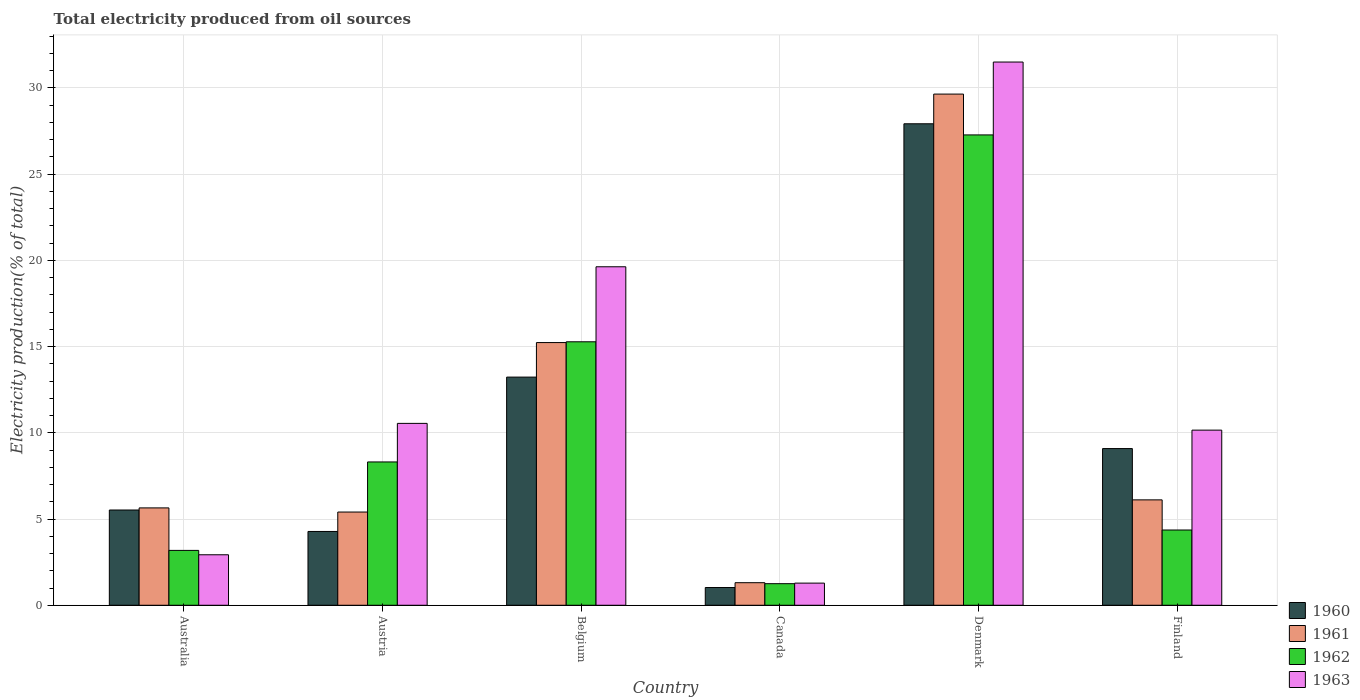How many different coloured bars are there?
Offer a very short reply. 4. How many groups of bars are there?
Provide a succinct answer. 6. Are the number of bars per tick equal to the number of legend labels?
Provide a short and direct response. Yes. How many bars are there on the 4th tick from the right?
Provide a short and direct response. 4. What is the label of the 4th group of bars from the left?
Your answer should be compact. Canada. In how many cases, is the number of bars for a given country not equal to the number of legend labels?
Offer a very short reply. 0. What is the total electricity produced in 1963 in Belgium?
Provide a succinct answer. 19.63. Across all countries, what is the maximum total electricity produced in 1960?
Give a very brief answer. 27.92. Across all countries, what is the minimum total electricity produced in 1961?
Make the answer very short. 1.31. In which country was the total electricity produced in 1962 minimum?
Provide a succinct answer. Canada. What is the total total electricity produced in 1962 in the graph?
Keep it short and to the point. 59.67. What is the difference between the total electricity produced in 1960 in Belgium and that in Canada?
Provide a short and direct response. 12.2. What is the difference between the total electricity produced in 1962 in Finland and the total electricity produced in 1960 in Austria?
Provide a succinct answer. 0.08. What is the average total electricity produced in 1961 per country?
Your response must be concise. 10.56. What is the difference between the total electricity produced of/in 1963 and total electricity produced of/in 1961 in Belgium?
Your answer should be compact. 4.4. What is the ratio of the total electricity produced in 1961 in Belgium to that in Denmark?
Make the answer very short. 0.51. What is the difference between the highest and the second highest total electricity produced in 1961?
Your response must be concise. 23.53. What is the difference between the highest and the lowest total electricity produced in 1963?
Provide a succinct answer. 30.22. In how many countries, is the total electricity produced in 1963 greater than the average total electricity produced in 1963 taken over all countries?
Provide a succinct answer. 2. What does the 1st bar from the right in Canada represents?
Your answer should be very brief. 1963. Is it the case that in every country, the sum of the total electricity produced in 1963 and total electricity produced in 1960 is greater than the total electricity produced in 1961?
Give a very brief answer. Yes. How many bars are there?
Offer a very short reply. 24. How many countries are there in the graph?
Your response must be concise. 6. Are the values on the major ticks of Y-axis written in scientific E-notation?
Your response must be concise. No. Does the graph contain any zero values?
Ensure brevity in your answer.  No. What is the title of the graph?
Keep it short and to the point. Total electricity produced from oil sources. Does "1991" appear as one of the legend labels in the graph?
Offer a terse response. No. What is the label or title of the X-axis?
Provide a succinct answer. Country. What is the Electricity production(% of total) of 1960 in Australia?
Offer a very short reply. 5.52. What is the Electricity production(% of total) of 1961 in Australia?
Provide a short and direct response. 5.65. What is the Electricity production(% of total) of 1962 in Australia?
Provide a short and direct response. 3.18. What is the Electricity production(% of total) of 1963 in Australia?
Your answer should be compact. 2.93. What is the Electricity production(% of total) in 1960 in Austria?
Provide a short and direct response. 4.28. What is the Electricity production(% of total) in 1961 in Austria?
Ensure brevity in your answer.  5.41. What is the Electricity production(% of total) in 1962 in Austria?
Make the answer very short. 8.31. What is the Electricity production(% of total) of 1963 in Austria?
Provide a succinct answer. 10.55. What is the Electricity production(% of total) in 1960 in Belgium?
Your answer should be compact. 13.23. What is the Electricity production(% of total) of 1961 in Belgium?
Your response must be concise. 15.23. What is the Electricity production(% of total) in 1962 in Belgium?
Provide a short and direct response. 15.28. What is the Electricity production(% of total) in 1963 in Belgium?
Ensure brevity in your answer.  19.63. What is the Electricity production(% of total) of 1960 in Canada?
Offer a very short reply. 1.03. What is the Electricity production(% of total) in 1961 in Canada?
Provide a short and direct response. 1.31. What is the Electricity production(% of total) of 1962 in Canada?
Keep it short and to the point. 1.25. What is the Electricity production(% of total) of 1963 in Canada?
Your answer should be very brief. 1.28. What is the Electricity production(% of total) in 1960 in Denmark?
Provide a short and direct response. 27.92. What is the Electricity production(% of total) in 1961 in Denmark?
Offer a terse response. 29.65. What is the Electricity production(% of total) in 1962 in Denmark?
Provide a succinct answer. 27.28. What is the Electricity production(% of total) of 1963 in Denmark?
Offer a very short reply. 31.51. What is the Electricity production(% of total) in 1960 in Finland?
Your answer should be very brief. 9.09. What is the Electricity production(% of total) in 1961 in Finland?
Offer a terse response. 6.11. What is the Electricity production(% of total) of 1962 in Finland?
Your answer should be very brief. 4.36. What is the Electricity production(% of total) in 1963 in Finland?
Your response must be concise. 10.16. Across all countries, what is the maximum Electricity production(% of total) in 1960?
Provide a short and direct response. 27.92. Across all countries, what is the maximum Electricity production(% of total) in 1961?
Provide a short and direct response. 29.65. Across all countries, what is the maximum Electricity production(% of total) in 1962?
Your response must be concise. 27.28. Across all countries, what is the maximum Electricity production(% of total) of 1963?
Ensure brevity in your answer.  31.51. Across all countries, what is the minimum Electricity production(% of total) in 1960?
Your answer should be very brief. 1.03. Across all countries, what is the minimum Electricity production(% of total) in 1961?
Make the answer very short. 1.31. Across all countries, what is the minimum Electricity production(% of total) of 1962?
Give a very brief answer. 1.25. Across all countries, what is the minimum Electricity production(% of total) of 1963?
Offer a very short reply. 1.28. What is the total Electricity production(% of total) of 1960 in the graph?
Keep it short and to the point. 61.08. What is the total Electricity production(% of total) in 1961 in the graph?
Your answer should be very brief. 63.36. What is the total Electricity production(% of total) of 1962 in the graph?
Offer a very short reply. 59.67. What is the total Electricity production(% of total) of 1963 in the graph?
Your answer should be very brief. 76.05. What is the difference between the Electricity production(% of total) in 1960 in Australia and that in Austria?
Your answer should be compact. 1.24. What is the difference between the Electricity production(% of total) of 1961 in Australia and that in Austria?
Your answer should be very brief. 0.24. What is the difference between the Electricity production(% of total) of 1962 in Australia and that in Austria?
Make the answer very short. -5.13. What is the difference between the Electricity production(% of total) of 1963 in Australia and that in Austria?
Offer a very short reply. -7.62. What is the difference between the Electricity production(% of total) of 1960 in Australia and that in Belgium?
Offer a terse response. -7.71. What is the difference between the Electricity production(% of total) of 1961 in Australia and that in Belgium?
Make the answer very short. -9.59. What is the difference between the Electricity production(% of total) in 1962 in Australia and that in Belgium?
Ensure brevity in your answer.  -12.1. What is the difference between the Electricity production(% of total) of 1963 in Australia and that in Belgium?
Offer a terse response. -16.7. What is the difference between the Electricity production(% of total) of 1960 in Australia and that in Canada?
Offer a terse response. 4.5. What is the difference between the Electricity production(% of total) in 1961 in Australia and that in Canada?
Your answer should be compact. 4.34. What is the difference between the Electricity production(% of total) of 1962 in Australia and that in Canada?
Your response must be concise. 1.93. What is the difference between the Electricity production(% of total) in 1963 in Australia and that in Canada?
Ensure brevity in your answer.  1.64. What is the difference between the Electricity production(% of total) of 1960 in Australia and that in Denmark?
Provide a succinct answer. -22.4. What is the difference between the Electricity production(% of total) of 1961 in Australia and that in Denmark?
Offer a very short reply. -24. What is the difference between the Electricity production(% of total) of 1962 in Australia and that in Denmark?
Keep it short and to the point. -24.1. What is the difference between the Electricity production(% of total) in 1963 in Australia and that in Denmark?
Ensure brevity in your answer.  -28.58. What is the difference between the Electricity production(% of total) of 1960 in Australia and that in Finland?
Offer a very short reply. -3.56. What is the difference between the Electricity production(% of total) in 1961 in Australia and that in Finland?
Provide a succinct answer. -0.47. What is the difference between the Electricity production(% of total) in 1962 in Australia and that in Finland?
Your response must be concise. -1.18. What is the difference between the Electricity production(% of total) of 1963 in Australia and that in Finland?
Ensure brevity in your answer.  -7.23. What is the difference between the Electricity production(% of total) of 1960 in Austria and that in Belgium?
Keep it short and to the point. -8.95. What is the difference between the Electricity production(% of total) in 1961 in Austria and that in Belgium?
Keep it short and to the point. -9.83. What is the difference between the Electricity production(% of total) in 1962 in Austria and that in Belgium?
Your answer should be compact. -6.97. What is the difference between the Electricity production(% of total) in 1963 in Austria and that in Belgium?
Make the answer very short. -9.08. What is the difference between the Electricity production(% of total) in 1960 in Austria and that in Canada?
Ensure brevity in your answer.  3.25. What is the difference between the Electricity production(% of total) of 1961 in Austria and that in Canada?
Your response must be concise. 4.1. What is the difference between the Electricity production(% of total) in 1962 in Austria and that in Canada?
Make the answer very short. 7.06. What is the difference between the Electricity production(% of total) in 1963 in Austria and that in Canada?
Your response must be concise. 9.26. What is the difference between the Electricity production(% of total) of 1960 in Austria and that in Denmark?
Give a very brief answer. -23.64. What is the difference between the Electricity production(% of total) of 1961 in Austria and that in Denmark?
Your response must be concise. -24.24. What is the difference between the Electricity production(% of total) of 1962 in Austria and that in Denmark?
Ensure brevity in your answer.  -18.97. What is the difference between the Electricity production(% of total) of 1963 in Austria and that in Denmark?
Your response must be concise. -20.96. What is the difference between the Electricity production(% of total) of 1960 in Austria and that in Finland?
Offer a terse response. -4.81. What is the difference between the Electricity production(% of total) in 1961 in Austria and that in Finland?
Keep it short and to the point. -0.71. What is the difference between the Electricity production(% of total) of 1962 in Austria and that in Finland?
Give a very brief answer. 3.95. What is the difference between the Electricity production(% of total) of 1963 in Austria and that in Finland?
Ensure brevity in your answer.  0.39. What is the difference between the Electricity production(% of total) of 1960 in Belgium and that in Canada?
Your answer should be compact. 12.2. What is the difference between the Electricity production(% of total) of 1961 in Belgium and that in Canada?
Your response must be concise. 13.93. What is the difference between the Electricity production(% of total) of 1962 in Belgium and that in Canada?
Your response must be concise. 14.03. What is the difference between the Electricity production(% of total) in 1963 in Belgium and that in Canada?
Give a very brief answer. 18.35. What is the difference between the Electricity production(% of total) in 1960 in Belgium and that in Denmark?
Your answer should be very brief. -14.69. What is the difference between the Electricity production(% of total) in 1961 in Belgium and that in Denmark?
Keep it short and to the point. -14.41. What is the difference between the Electricity production(% of total) of 1962 in Belgium and that in Denmark?
Your answer should be compact. -12. What is the difference between the Electricity production(% of total) in 1963 in Belgium and that in Denmark?
Give a very brief answer. -11.87. What is the difference between the Electricity production(% of total) of 1960 in Belgium and that in Finland?
Provide a succinct answer. 4.14. What is the difference between the Electricity production(% of total) in 1961 in Belgium and that in Finland?
Your answer should be very brief. 9.12. What is the difference between the Electricity production(% of total) in 1962 in Belgium and that in Finland?
Offer a terse response. 10.92. What is the difference between the Electricity production(% of total) of 1963 in Belgium and that in Finland?
Offer a very short reply. 9.47. What is the difference between the Electricity production(% of total) in 1960 in Canada and that in Denmark?
Keep it short and to the point. -26.9. What is the difference between the Electricity production(% of total) of 1961 in Canada and that in Denmark?
Give a very brief answer. -28.34. What is the difference between the Electricity production(% of total) in 1962 in Canada and that in Denmark?
Your answer should be compact. -26.03. What is the difference between the Electricity production(% of total) of 1963 in Canada and that in Denmark?
Give a very brief answer. -30.22. What is the difference between the Electricity production(% of total) of 1960 in Canada and that in Finland?
Your response must be concise. -8.06. What is the difference between the Electricity production(% of total) in 1961 in Canada and that in Finland?
Give a very brief answer. -4.8. What is the difference between the Electricity production(% of total) in 1962 in Canada and that in Finland?
Ensure brevity in your answer.  -3.11. What is the difference between the Electricity production(% of total) in 1963 in Canada and that in Finland?
Your response must be concise. -8.87. What is the difference between the Electricity production(% of total) in 1960 in Denmark and that in Finland?
Your answer should be very brief. 18.84. What is the difference between the Electricity production(% of total) of 1961 in Denmark and that in Finland?
Make the answer very short. 23.53. What is the difference between the Electricity production(% of total) of 1962 in Denmark and that in Finland?
Keep it short and to the point. 22.91. What is the difference between the Electricity production(% of total) in 1963 in Denmark and that in Finland?
Offer a very short reply. 21.35. What is the difference between the Electricity production(% of total) of 1960 in Australia and the Electricity production(% of total) of 1961 in Austria?
Your response must be concise. 0.12. What is the difference between the Electricity production(% of total) in 1960 in Australia and the Electricity production(% of total) in 1962 in Austria?
Ensure brevity in your answer.  -2.79. What is the difference between the Electricity production(% of total) in 1960 in Australia and the Electricity production(% of total) in 1963 in Austria?
Your answer should be very brief. -5.02. What is the difference between the Electricity production(% of total) of 1961 in Australia and the Electricity production(% of total) of 1962 in Austria?
Make the answer very short. -2.67. What is the difference between the Electricity production(% of total) in 1961 in Australia and the Electricity production(% of total) in 1963 in Austria?
Make the answer very short. -4.9. What is the difference between the Electricity production(% of total) of 1962 in Australia and the Electricity production(% of total) of 1963 in Austria?
Your answer should be very brief. -7.37. What is the difference between the Electricity production(% of total) in 1960 in Australia and the Electricity production(% of total) in 1961 in Belgium?
Your answer should be very brief. -9.71. What is the difference between the Electricity production(% of total) in 1960 in Australia and the Electricity production(% of total) in 1962 in Belgium?
Keep it short and to the point. -9.76. What is the difference between the Electricity production(% of total) of 1960 in Australia and the Electricity production(% of total) of 1963 in Belgium?
Your answer should be very brief. -14.11. What is the difference between the Electricity production(% of total) of 1961 in Australia and the Electricity production(% of total) of 1962 in Belgium?
Provide a short and direct response. -9.63. What is the difference between the Electricity production(% of total) of 1961 in Australia and the Electricity production(% of total) of 1963 in Belgium?
Give a very brief answer. -13.98. What is the difference between the Electricity production(% of total) of 1962 in Australia and the Electricity production(% of total) of 1963 in Belgium?
Make the answer very short. -16.45. What is the difference between the Electricity production(% of total) in 1960 in Australia and the Electricity production(% of total) in 1961 in Canada?
Ensure brevity in your answer.  4.22. What is the difference between the Electricity production(% of total) in 1960 in Australia and the Electricity production(% of total) in 1962 in Canada?
Provide a short and direct response. 4.27. What is the difference between the Electricity production(% of total) in 1960 in Australia and the Electricity production(% of total) in 1963 in Canada?
Offer a very short reply. 4.24. What is the difference between the Electricity production(% of total) of 1961 in Australia and the Electricity production(% of total) of 1962 in Canada?
Offer a very short reply. 4.4. What is the difference between the Electricity production(% of total) in 1961 in Australia and the Electricity production(% of total) in 1963 in Canada?
Make the answer very short. 4.36. What is the difference between the Electricity production(% of total) of 1962 in Australia and the Electricity production(% of total) of 1963 in Canada?
Your answer should be compact. 1.9. What is the difference between the Electricity production(% of total) of 1960 in Australia and the Electricity production(% of total) of 1961 in Denmark?
Make the answer very short. -24.12. What is the difference between the Electricity production(% of total) in 1960 in Australia and the Electricity production(% of total) in 1962 in Denmark?
Ensure brevity in your answer.  -21.75. What is the difference between the Electricity production(% of total) in 1960 in Australia and the Electricity production(% of total) in 1963 in Denmark?
Provide a succinct answer. -25.98. What is the difference between the Electricity production(% of total) of 1961 in Australia and the Electricity production(% of total) of 1962 in Denmark?
Your response must be concise. -21.63. What is the difference between the Electricity production(% of total) of 1961 in Australia and the Electricity production(% of total) of 1963 in Denmark?
Make the answer very short. -25.86. What is the difference between the Electricity production(% of total) of 1962 in Australia and the Electricity production(% of total) of 1963 in Denmark?
Your answer should be very brief. -28.32. What is the difference between the Electricity production(% of total) in 1960 in Australia and the Electricity production(% of total) in 1961 in Finland?
Provide a succinct answer. -0.59. What is the difference between the Electricity production(% of total) of 1960 in Australia and the Electricity production(% of total) of 1962 in Finland?
Keep it short and to the point. 1.16. What is the difference between the Electricity production(% of total) in 1960 in Australia and the Electricity production(% of total) in 1963 in Finland?
Ensure brevity in your answer.  -4.63. What is the difference between the Electricity production(% of total) of 1961 in Australia and the Electricity production(% of total) of 1962 in Finland?
Keep it short and to the point. 1.28. What is the difference between the Electricity production(% of total) in 1961 in Australia and the Electricity production(% of total) in 1963 in Finland?
Provide a short and direct response. -4.51. What is the difference between the Electricity production(% of total) in 1962 in Australia and the Electricity production(% of total) in 1963 in Finland?
Provide a succinct answer. -6.98. What is the difference between the Electricity production(% of total) in 1960 in Austria and the Electricity production(% of total) in 1961 in Belgium?
Provide a succinct answer. -10.95. What is the difference between the Electricity production(% of total) in 1960 in Austria and the Electricity production(% of total) in 1962 in Belgium?
Offer a very short reply. -11. What is the difference between the Electricity production(% of total) of 1960 in Austria and the Electricity production(% of total) of 1963 in Belgium?
Provide a short and direct response. -15.35. What is the difference between the Electricity production(% of total) of 1961 in Austria and the Electricity production(% of total) of 1962 in Belgium?
Keep it short and to the point. -9.87. What is the difference between the Electricity production(% of total) in 1961 in Austria and the Electricity production(% of total) in 1963 in Belgium?
Your answer should be compact. -14.22. What is the difference between the Electricity production(% of total) of 1962 in Austria and the Electricity production(% of total) of 1963 in Belgium?
Ensure brevity in your answer.  -11.32. What is the difference between the Electricity production(% of total) of 1960 in Austria and the Electricity production(% of total) of 1961 in Canada?
Make the answer very short. 2.97. What is the difference between the Electricity production(% of total) in 1960 in Austria and the Electricity production(% of total) in 1962 in Canada?
Give a very brief answer. 3.03. What is the difference between the Electricity production(% of total) in 1960 in Austria and the Electricity production(% of total) in 1963 in Canada?
Give a very brief answer. 3. What is the difference between the Electricity production(% of total) in 1961 in Austria and the Electricity production(% of total) in 1962 in Canada?
Your answer should be very brief. 4.16. What is the difference between the Electricity production(% of total) in 1961 in Austria and the Electricity production(% of total) in 1963 in Canada?
Your response must be concise. 4.12. What is the difference between the Electricity production(% of total) in 1962 in Austria and the Electricity production(% of total) in 1963 in Canada?
Your answer should be very brief. 7.03. What is the difference between the Electricity production(% of total) of 1960 in Austria and the Electricity production(% of total) of 1961 in Denmark?
Offer a terse response. -25.37. What is the difference between the Electricity production(% of total) of 1960 in Austria and the Electricity production(% of total) of 1962 in Denmark?
Give a very brief answer. -23. What is the difference between the Electricity production(% of total) in 1960 in Austria and the Electricity production(% of total) in 1963 in Denmark?
Keep it short and to the point. -27.22. What is the difference between the Electricity production(% of total) in 1961 in Austria and the Electricity production(% of total) in 1962 in Denmark?
Offer a very short reply. -21.87. What is the difference between the Electricity production(% of total) in 1961 in Austria and the Electricity production(% of total) in 1963 in Denmark?
Make the answer very short. -26.1. What is the difference between the Electricity production(% of total) in 1962 in Austria and the Electricity production(% of total) in 1963 in Denmark?
Your answer should be very brief. -23.19. What is the difference between the Electricity production(% of total) of 1960 in Austria and the Electricity production(% of total) of 1961 in Finland?
Your answer should be very brief. -1.83. What is the difference between the Electricity production(% of total) in 1960 in Austria and the Electricity production(% of total) in 1962 in Finland?
Your answer should be compact. -0.08. What is the difference between the Electricity production(% of total) of 1960 in Austria and the Electricity production(% of total) of 1963 in Finland?
Make the answer very short. -5.88. What is the difference between the Electricity production(% of total) in 1961 in Austria and the Electricity production(% of total) in 1962 in Finland?
Your response must be concise. 1.04. What is the difference between the Electricity production(% of total) in 1961 in Austria and the Electricity production(% of total) in 1963 in Finland?
Ensure brevity in your answer.  -4.75. What is the difference between the Electricity production(% of total) of 1962 in Austria and the Electricity production(% of total) of 1963 in Finland?
Your answer should be compact. -1.84. What is the difference between the Electricity production(% of total) of 1960 in Belgium and the Electricity production(% of total) of 1961 in Canada?
Give a very brief answer. 11.92. What is the difference between the Electricity production(% of total) of 1960 in Belgium and the Electricity production(% of total) of 1962 in Canada?
Your answer should be very brief. 11.98. What is the difference between the Electricity production(% of total) in 1960 in Belgium and the Electricity production(% of total) in 1963 in Canada?
Provide a succinct answer. 11.95. What is the difference between the Electricity production(% of total) of 1961 in Belgium and the Electricity production(% of total) of 1962 in Canada?
Ensure brevity in your answer.  13.98. What is the difference between the Electricity production(% of total) of 1961 in Belgium and the Electricity production(% of total) of 1963 in Canada?
Your response must be concise. 13.95. What is the difference between the Electricity production(% of total) of 1962 in Belgium and the Electricity production(% of total) of 1963 in Canada?
Your answer should be very brief. 14. What is the difference between the Electricity production(% of total) of 1960 in Belgium and the Electricity production(% of total) of 1961 in Denmark?
Offer a very short reply. -16.41. What is the difference between the Electricity production(% of total) in 1960 in Belgium and the Electricity production(% of total) in 1962 in Denmark?
Your answer should be very brief. -14.05. What is the difference between the Electricity production(% of total) in 1960 in Belgium and the Electricity production(% of total) in 1963 in Denmark?
Give a very brief answer. -18.27. What is the difference between the Electricity production(% of total) in 1961 in Belgium and the Electricity production(% of total) in 1962 in Denmark?
Your response must be concise. -12.04. What is the difference between the Electricity production(% of total) in 1961 in Belgium and the Electricity production(% of total) in 1963 in Denmark?
Offer a very short reply. -16.27. What is the difference between the Electricity production(% of total) in 1962 in Belgium and the Electricity production(% of total) in 1963 in Denmark?
Ensure brevity in your answer.  -16.22. What is the difference between the Electricity production(% of total) in 1960 in Belgium and the Electricity production(% of total) in 1961 in Finland?
Offer a terse response. 7.12. What is the difference between the Electricity production(% of total) of 1960 in Belgium and the Electricity production(% of total) of 1962 in Finland?
Your response must be concise. 8.87. What is the difference between the Electricity production(% of total) of 1960 in Belgium and the Electricity production(% of total) of 1963 in Finland?
Your answer should be very brief. 3.08. What is the difference between the Electricity production(% of total) in 1961 in Belgium and the Electricity production(% of total) in 1962 in Finland?
Your answer should be compact. 10.87. What is the difference between the Electricity production(% of total) of 1961 in Belgium and the Electricity production(% of total) of 1963 in Finland?
Provide a succinct answer. 5.08. What is the difference between the Electricity production(% of total) in 1962 in Belgium and the Electricity production(% of total) in 1963 in Finland?
Your answer should be very brief. 5.12. What is the difference between the Electricity production(% of total) of 1960 in Canada and the Electricity production(% of total) of 1961 in Denmark?
Your answer should be very brief. -28.62. What is the difference between the Electricity production(% of total) of 1960 in Canada and the Electricity production(% of total) of 1962 in Denmark?
Offer a very short reply. -26.25. What is the difference between the Electricity production(% of total) of 1960 in Canada and the Electricity production(% of total) of 1963 in Denmark?
Your answer should be very brief. -30.48. What is the difference between the Electricity production(% of total) of 1961 in Canada and the Electricity production(% of total) of 1962 in Denmark?
Your answer should be compact. -25.97. What is the difference between the Electricity production(% of total) of 1961 in Canada and the Electricity production(% of total) of 1963 in Denmark?
Your response must be concise. -30.2. What is the difference between the Electricity production(% of total) in 1962 in Canada and the Electricity production(% of total) in 1963 in Denmark?
Give a very brief answer. -30.25. What is the difference between the Electricity production(% of total) in 1960 in Canada and the Electricity production(% of total) in 1961 in Finland?
Give a very brief answer. -5.08. What is the difference between the Electricity production(% of total) of 1960 in Canada and the Electricity production(% of total) of 1962 in Finland?
Keep it short and to the point. -3.34. What is the difference between the Electricity production(% of total) of 1960 in Canada and the Electricity production(% of total) of 1963 in Finland?
Your answer should be compact. -9.13. What is the difference between the Electricity production(% of total) of 1961 in Canada and the Electricity production(% of total) of 1962 in Finland?
Your answer should be very brief. -3.06. What is the difference between the Electricity production(% of total) in 1961 in Canada and the Electricity production(% of total) in 1963 in Finland?
Give a very brief answer. -8.85. What is the difference between the Electricity production(% of total) in 1962 in Canada and the Electricity production(% of total) in 1963 in Finland?
Offer a terse response. -8.91. What is the difference between the Electricity production(% of total) of 1960 in Denmark and the Electricity production(% of total) of 1961 in Finland?
Offer a very short reply. 21.81. What is the difference between the Electricity production(% of total) of 1960 in Denmark and the Electricity production(% of total) of 1962 in Finland?
Offer a terse response. 23.56. What is the difference between the Electricity production(% of total) in 1960 in Denmark and the Electricity production(% of total) in 1963 in Finland?
Give a very brief answer. 17.77. What is the difference between the Electricity production(% of total) of 1961 in Denmark and the Electricity production(% of total) of 1962 in Finland?
Make the answer very short. 25.28. What is the difference between the Electricity production(% of total) of 1961 in Denmark and the Electricity production(% of total) of 1963 in Finland?
Your answer should be compact. 19.49. What is the difference between the Electricity production(% of total) of 1962 in Denmark and the Electricity production(% of total) of 1963 in Finland?
Your response must be concise. 17.12. What is the average Electricity production(% of total) of 1960 per country?
Keep it short and to the point. 10.18. What is the average Electricity production(% of total) of 1961 per country?
Offer a very short reply. 10.56. What is the average Electricity production(% of total) in 1962 per country?
Your answer should be compact. 9.94. What is the average Electricity production(% of total) in 1963 per country?
Offer a very short reply. 12.68. What is the difference between the Electricity production(% of total) of 1960 and Electricity production(% of total) of 1961 in Australia?
Your answer should be very brief. -0.12. What is the difference between the Electricity production(% of total) in 1960 and Electricity production(% of total) in 1962 in Australia?
Your answer should be very brief. 2.34. What is the difference between the Electricity production(% of total) in 1960 and Electricity production(% of total) in 1963 in Australia?
Ensure brevity in your answer.  2.6. What is the difference between the Electricity production(% of total) of 1961 and Electricity production(% of total) of 1962 in Australia?
Provide a short and direct response. 2.47. What is the difference between the Electricity production(% of total) in 1961 and Electricity production(% of total) in 1963 in Australia?
Provide a succinct answer. 2.72. What is the difference between the Electricity production(% of total) in 1962 and Electricity production(% of total) in 1963 in Australia?
Offer a very short reply. 0.25. What is the difference between the Electricity production(% of total) in 1960 and Electricity production(% of total) in 1961 in Austria?
Provide a succinct answer. -1.13. What is the difference between the Electricity production(% of total) in 1960 and Electricity production(% of total) in 1962 in Austria?
Keep it short and to the point. -4.03. What is the difference between the Electricity production(% of total) of 1960 and Electricity production(% of total) of 1963 in Austria?
Provide a short and direct response. -6.27. What is the difference between the Electricity production(% of total) of 1961 and Electricity production(% of total) of 1962 in Austria?
Your answer should be very brief. -2.91. What is the difference between the Electricity production(% of total) of 1961 and Electricity production(% of total) of 1963 in Austria?
Provide a short and direct response. -5.14. What is the difference between the Electricity production(% of total) in 1962 and Electricity production(% of total) in 1963 in Austria?
Keep it short and to the point. -2.24. What is the difference between the Electricity production(% of total) of 1960 and Electricity production(% of total) of 1961 in Belgium?
Offer a very short reply. -2. What is the difference between the Electricity production(% of total) in 1960 and Electricity production(% of total) in 1962 in Belgium?
Keep it short and to the point. -2.05. What is the difference between the Electricity production(% of total) in 1960 and Electricity production(% of total) in 1963 in Belgium?
Give a very brief answer. -6.4. What is the difference between the Electricity production(% of total) of 1961 and Electricity production(% of total) of 1962 in Belgium?
Provide a succinct answer. -0.05. What is the difference between the Electricity production(% of total) of 1961 and Electricity production(% of total) of 1963 in Belgium?
Make the answer very short. -4.4. What is the difference between the Electricity production(% of total) in 1962 and Electricity production(% of total) in 1963 in Belgium?
Give a very brief answer. -4.35. What is the difference between the Electricity production(% of total) in 1960 and Electricity production(% of total) in 1961 in Canada?
Provide a short and direct response. -0.28. What is the difference between the Electricity production(% of total) of 1960 and Electricity production(% of total) of 1962 in Canada?
Provide a short and direct response. -0.22. What is the difference between the Electricity production(% of total) in 1960 and Electricity production(% of total) in 1963 in Canada?
Offer a terse response. -0.26. What is the difference between the Electricity production(% of total) in 1961 and Electricity production(% of total) in 1962 in Canada?
Make the answer very short. 0.06. What is the difference between the Electricity production(% of total) in 1961 and Electricity production(% of total) in 1963 in Canada?
Offer a very short reply. 0.03. What is the difference between the Electricity production(% of total) of 1962 and Electricity production(% of total) of 1963 in Canada?
Ensure brevity in your answer.  -0.03. What is the difference between the Electricity production(% of total) of 1960 and Electricity production(% of total) of 1961 in Denmark?
Give a very brief answer. -1.72. What is the difference between the Electricity production(% of total) of 1960 and Electricity production(% of total) of 1962 in Denmark?
Offer a terse response. 0.65. What is the difference between the Electricity production(% of total) of 1960 and Electricity production(% of total) of 1963 in Denmark?
Make the answer very short. -3.58. What is the difference between the Electricity production(% of total) of 1961 and Electricity production(% of total) of 1962 in Denmark?
Offer a very short reply. 2.37. What is the difference between the Electricity production(% of total) in 1961 and Electricity production(% of total) in 1963 in Denmark?
Give a very brief answer. -1.86. What is the difference between the Electricity production(% of total) in 1962 and Electricity production(% of total) in 1963 in Denmark?
Your answer should be very brief. -4.23. What is the difference between the Electricity production(% of total) in 1960 and Electricity production(% of total) in 1961 in Finland?
Provide a succinct answer. 2.98. What is the difference between the Electricity production(% of total) of 1960 and Electricity production(% of total) of 1962 in Finland?
Ensure brevity in your answer.  4.72. What is the difference between the Electricity production(% of total) in 1960 and Electricity production(% of total) in 1963 in Finland?
Your answer should be very brief. -1.07. What is the difference between the Electricity production(% of total) of 1961 and Electricity production(% of total) of 1962 in Finland?
Provide a succinct answer. 1.75. What is the difference between the Electricity production(% of total) in 1961 and Electricity production(% of total) in 1963 in Finland?
Make the answer very short. -4.04. What is the difference between the Electricity production(% of total) of 1962 and Electricity production(% of total) of 1963 in Finland?
Your answer should be compact. -5.79. What is the ratio of the Electricity production(% of total) in 1960 in Australia to that in Austria?
Offer a very short reply. 1.29. What is the ratio of the Electricity production(% of total) in 1961 in Australia to that in Austria?
Offer a very short reply. 1.04. What is the ratio of the Electricity production(% of total) in 1962 in Australia to that in Austria?
Keep it short and to the point. 0.38. What is the ratio of the Electricity production(% of total) in 1963 in Australia to that in Austria?
Offer a very short reply. 0.28. What is the ratio of the Electricity production(% of total) of 1960 in Australia to that in Belgium?
Offer a very short reply. 0.42. What is the ratio of the Electricity production(% of total) in 1961 in Australia to that in Belgium?
Ensure brevity in your answer.  0.37. What is the ratio of the Electricity production(% of total) in 1962 in Australia to that in Belgium?
Provide a succinct answer. 0.21. What is the ratio of the Electricity production(% of total) of 1963 in Australia to that in Belgium?
Provide a short and direct response. 0.15. What is the ratio of the Electricity production(% of total) of 1960 in Australia to that in Canada?
Make the answer very short. 5.37. What is the ratio of the Electricity production(% of total) in 1961 in Australia to that in Canada?
Your answer should be very brief. 4.31. What is the ratio of the Electricity production(% of total) in 1962 in Australia to that in Canada?
Keep it short and to the point. 2.54. What is the ratio of the Electricity production(% of total) in 1963 in Australia to that in Canada?
Ensure brevity in your answer.  2.28. What is the ratio of the Electricity production(% of total) of 1960 in Australia to that in Denmark?
Your answer should be very brief. 0.2. What is the ratio of the Electricity production(% of total) of 1961 in Australia to that in Denmark?
Provide a succinct answer. 0.19. What is the ratio of the Electricity production(% of total) in 1962 in Australia to that in Denmark?
Offer a very short reply. 0.12. What is the ratio of the Electricity production(% of total) in 1963 in Australia to that in Denmark?
Offer a very short reply. 0.09. What is the ratio of the Electricity production(% of total) in 1960 in Australia to that in Finland?
Offer a very short reply. 0.61. What is the ratio of the Electricity production(% of total) of 1961 in Australia to that in Finland?
Offer a terse response. 0.92. What is the ratio of the Electricity production(% of total) of 1962 in Australia to that in Finland?
Your answer should be very brief. 0.73. What is the ratio of the Electricity production(% of total) of 1963 in Australia to that in Finland?
Give a very brief answer. 0.29. What is the ratio of the Electricity production(% of total) in 1960 in Austria to that in Belgium?
Your response must be concise. 0.32. What is the ratio of the Electricity production(% of total) in 1961 in Austria to that in Belgium?
Provide a succinct answer. 0.35. What is the ratio of the Electricity production(% of total) of 1962 in Austria to that in Belgium?
Your answer should be compact. 0.54. What is the ratio of the Electricity production(% of total) in 1963 in Austria to that in Belgium?
Offer a terse response. 0.54. What is the ratio of the Electricity production(% of total) in 1960 in Austria to that in Canada?
Give a very brief answer. 4.16. What is the ratio of the Electricity production(% of total) in 1961 in Austria to that in Canada?
Make the answer very short. 4.13. What is the ratio of the Electricity production(% of total) of 1962 in Austria to that in Canada?
Your answer should be compact. 6.64. What is the ratio of the Electricity production(% of total) in 1963 in Austria to that in Canada?
Provide a succinct answer. 8.22. What is the ratio of the Electricity production(% of total) of 1960 in Austria to that in Denmark?
Your answer should be very brief. 0.15. What is the ratio of the Electricity production(% of total) in 1961 in Austria to that in Denmark?
Make the answer very short. 0.18. What is the ratio of the Electricity production(% of total) of 1962 in Austria to that in Denmark?
Provide a short and direct response. 0.3. What is the ratio of the Electricity production(% of total) of 1963 in Austria to that in Denmark?
Give a very brief answer. 0.33. What is the ratio of the Electricity production(% of total) in 1960 in Austria to that in Finland?
Provide a short and direct response. 0.47. What is the ratio of the Electricity production(% of total) of 1961 in Austria to that in Finland?
Make the answer very short. 0.88. What is the ratio of the Electricity production(% of total) of 1962 in Austria to that in Finland?
Ensure brevity in your answer.  1.9. What is the ratio of the Electricity production(% of total) of 1963 in Austria to that in Finland?
Offer a terse response. 1.04. What is the ratio of the Electricity production(% of total) of 1960 in Belgium to that in Canada?
Offer a terse response. 12.86. What is the ratio of the Electricity production(% of total) of 1961 in Belgium to that in Canada?
Offer a terse response. 11.64. What is the ratio of the Electricity production(% of total) in 1962 in Belgium to that in Canada?
Give a very brief answer. 12.21. What is the ratio of the Electricity production(% of total) in 1963 in Belgium to that in Canada?
Ensure brevity in your answer.  15.29. What is the ratio of the Electricity production(% of total) in 1960 in Belgium to that in Denmark?
Ensure brevity in your answer.  0.47. What is the ratio of the Electricity production(% of total) of 1961 in Belgium to that in Denmark?
Offer a very short reply. 0.51. What is the ratio of the Electricity production(% of total) of 1962 in Belgium to that in Denmark?
Offer a very short reply. 0.56. What is the ratio of the Electricity production(% of total) of 1963 in Belgium to that in Denmark?
Your answer should be compact. 0.62. What is the ratio of the Electricity production(% of total) of 1960 in Belgium to that in Finland?
Give a very brief answer. 1.46. What is the ratio of the Electricity production(% of total) of 1961 in Belgium to that in Finland?
Your answer should be very brief. 2.49. What is the ratio of the Electricity production(% of total) in 1962 in Belgium to that in Finland?
Offer a very short reply. 3.5. What is the ratio of the Electricity production(% of total) in 1963 in Belgium to that in Finland?
Provide a short and direct response. 1.93. What is the ratio of the Electricity production(% of total) of 1960 in Canada to that in Denmark?
Keep it short and to the point. 0.04. What is the ratio of the Electricity production(% of total) of 1961 in Canada to that in Denmark?
Your answer should be compact. 0.04. What is the ratio of the Electricity production(% of total) of 1962 in Canada to that in Denmark?
Your response must be concise. 0.05. What is the ratio of the Electricity production(% of total) of 1963 in Canada to that in Denmark?
Provide a short and direct response. 0.04. What is the ratio of the Electricity production(% of total) in 1960 in Canada to that in Finland?
Keep it short and to the point. 0.11. What is the ratio of the Electricity production(% of total) in 1961 in Canada to that in Finland?
Ensure brevity in your answer.  0.21. What is the ratio of the Electricity production(% of total) of 1962 in Canada to that in Finland?
Ensure brevity in your answer.  0.29. What is the ratio of the Electricity production(% of total) of 1963 in Canada to that in Finland?
Provide a short and direct response. 0.13. What is the ratio of the Electricity production(% of total) in 1960 in Denmark to that in Finland?
Give a very brief answer. 3.07. What is the ratio of the Electricity production(% of total) in 1961 in Denmark to that in Finland?
Offer a terse response. 4.85. What is the ratio of the Electricity production(% of total) in 1962 in Denmark to that in Finland?
Provide a short and direct response. 6.25. What is the ratio of the Electricity production(% of total) of 1963 in Denmark to that in Finland?
Your answer should be very brief. 3.1. What is the difference between the highest and the second highest Electricity production(% of total) of 1960?
Your response must be concise. 14.69. What is the difference between the highest and the second highest Electricity production(% of total) of 1961?
Keep it short and to the point. 14.41. What is the difference between the highest and the second highest Electricity production(% of total) of 1962?
Make the answer very short. 12. What is the difference between the highest and the second highest Electricity production(% of total) in 1963?
Offer a very short reply. 11.87. What is the difference between the highest and the lowest Electricity production(% of total) in 1960?
Offer a terse response. 26.9. What is the difference between the highest and the lowest Electricity production(% of total) of 1961?
Offer a very short reply. 28.34. What is the difference between the highest and the lowest Electricity production(% of total) of 1962?
Offer a very short reply. 26.03. What is the difference between the highest and the lowest Electricity production(% of total) of 1963?
Provide a succinct answer. 30.22. 